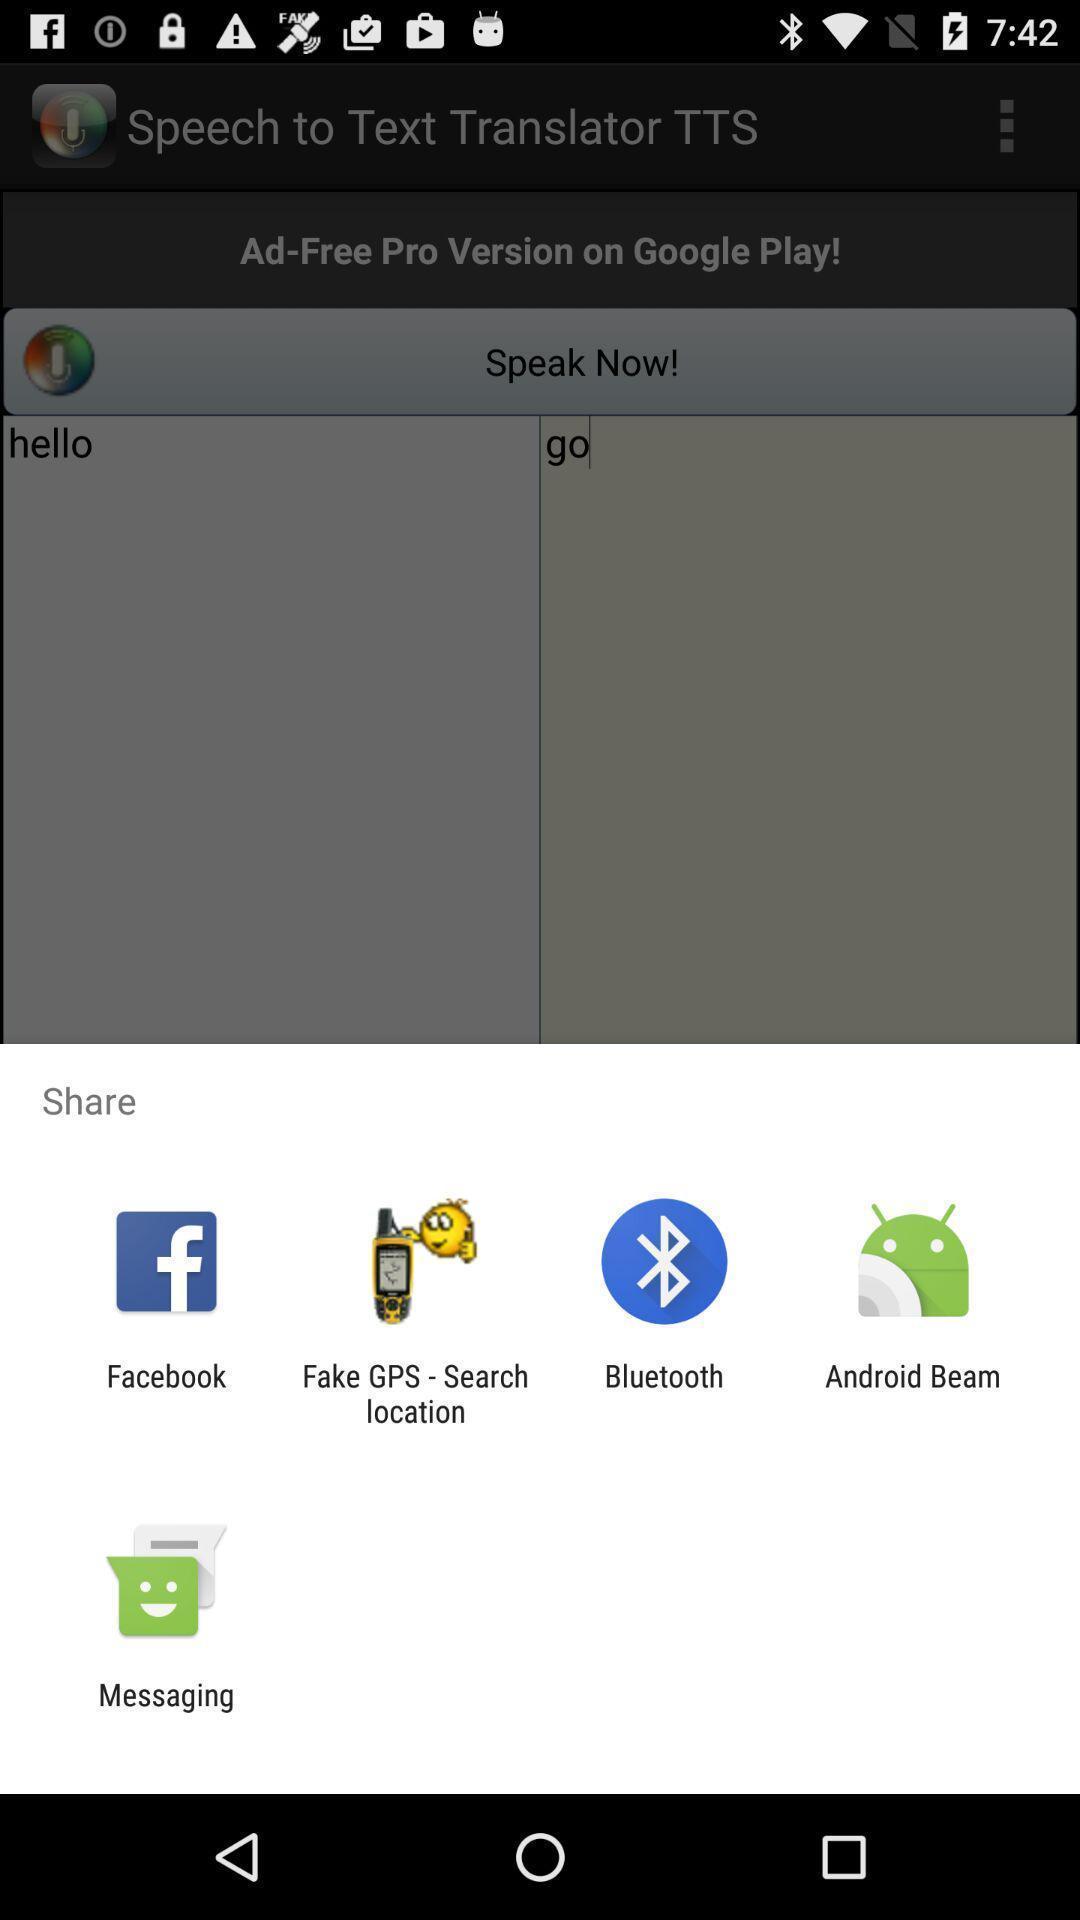Summarize the information in this screenshot. Screen shows share option with multiple other applications. 